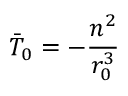<formula> <loc_0><loc_0><loc_500><loc_500>\ B a r { T } _ { 0 } = - \frac { n ^ { 2 } } { r _ { 0 } ^ { 3 } }</formula> 